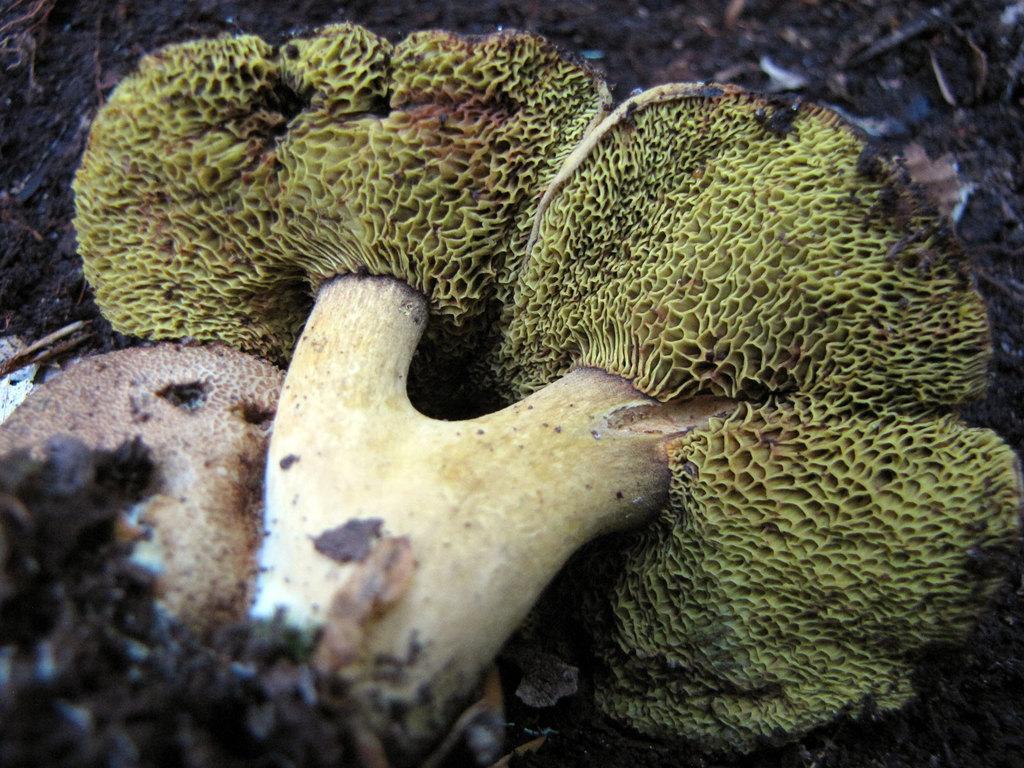Could you give a brief overview of what you see in this image? In this picture we can see mushrooms and fungus. 